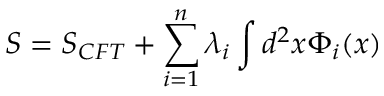<formula> <loc_0><loc_0><loc_500><loc_500>S = S _ { C F T } + \sum _ { i = 1 } ^ { n } \lambda _ { i } \int d ^ { 2 } x \Phi _ { i } ( x )</formula> 